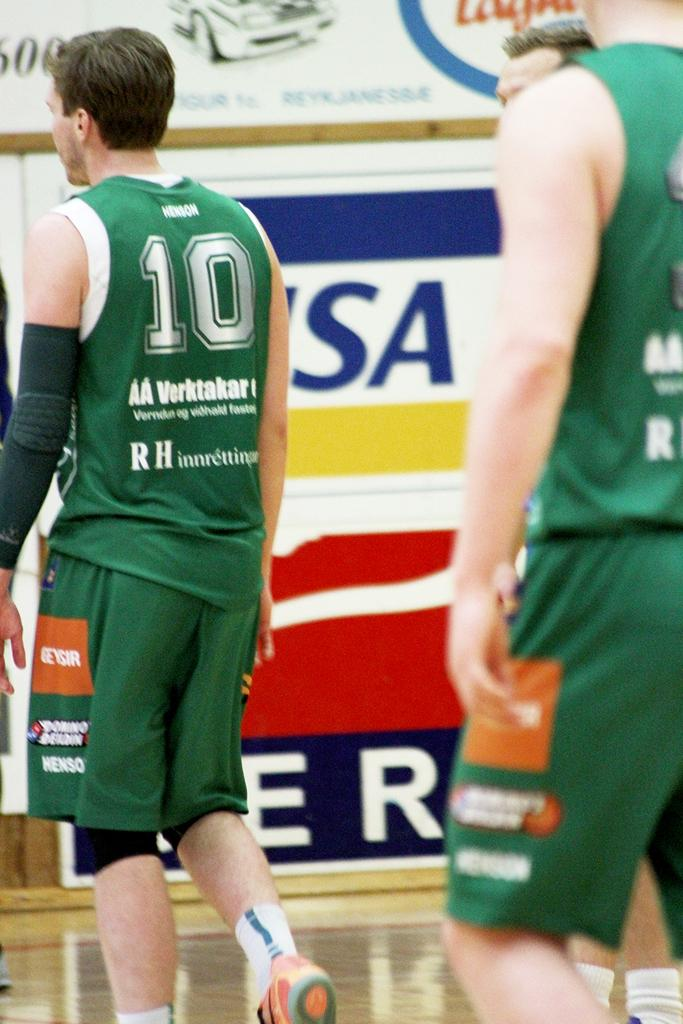<image>
Give a short and clear explanation of the subsequent image. Player 10 has an orange square on his shorts that reads geysir. 